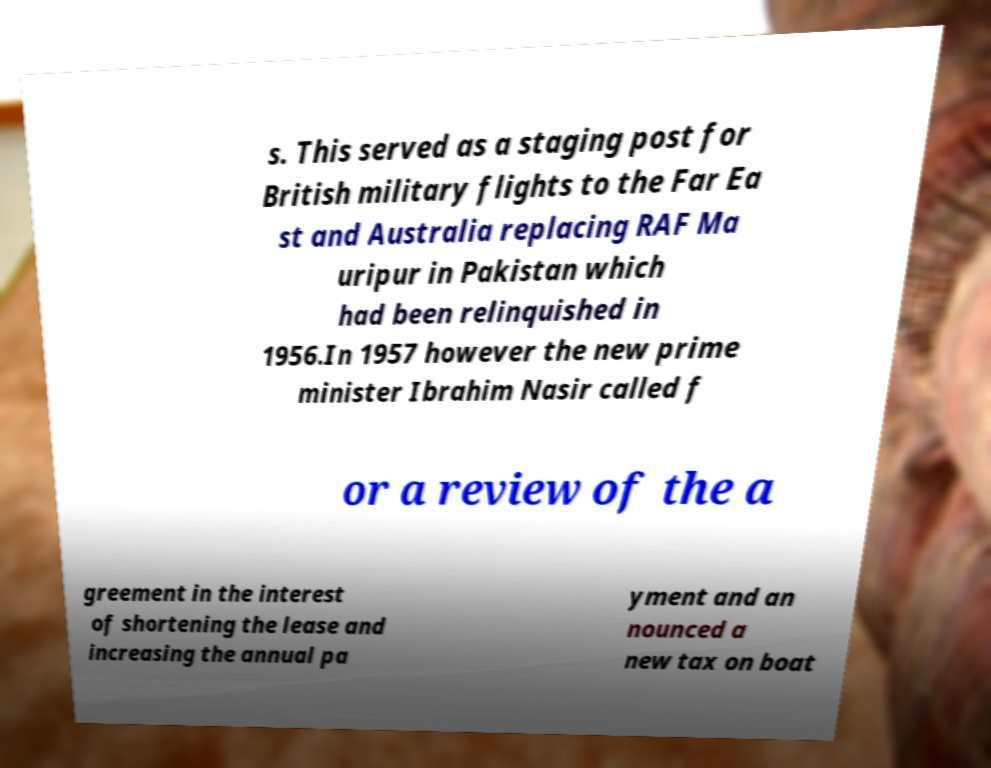What messages or text are displayed in this image? I need them in a readable, typed format. s. This served as a staging post for British military flights to the Far Ea st and Australia replacing RAF Ma uripur in Pakistan which had been relinquished in 1956.In 1957 however the new prime minister Ibrahim Nasir called f or a review of the a greement in the interest of shortening the lease and increasing the annual pa yment and an nounced a new tax on boat 